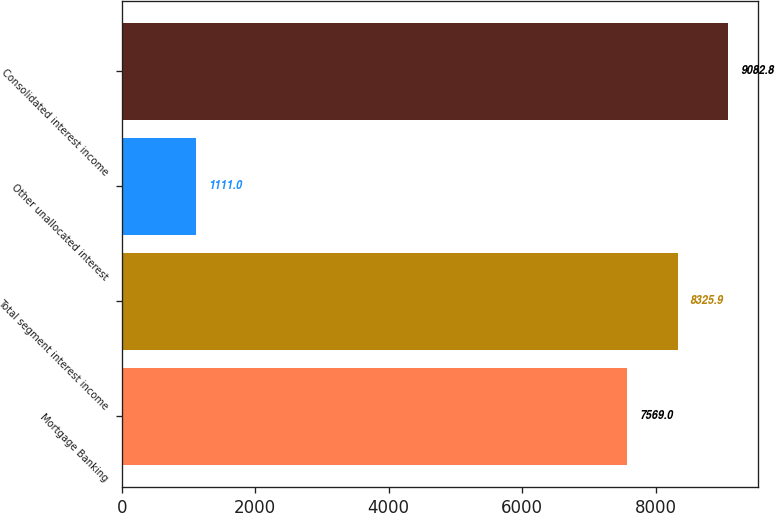Convert chart to OTSL. <chart><loc_0><loc_0><loc_500><loc_500><bar_chart><fcel>Mortgage Banking<fcel>Total segment interest income<fcel>Other unallocated interest<fcel>Consolidated interest income<nl><fcel>7569<fcel>8325.9<fcel>1111<fcel>9082.8<nl></chart> 